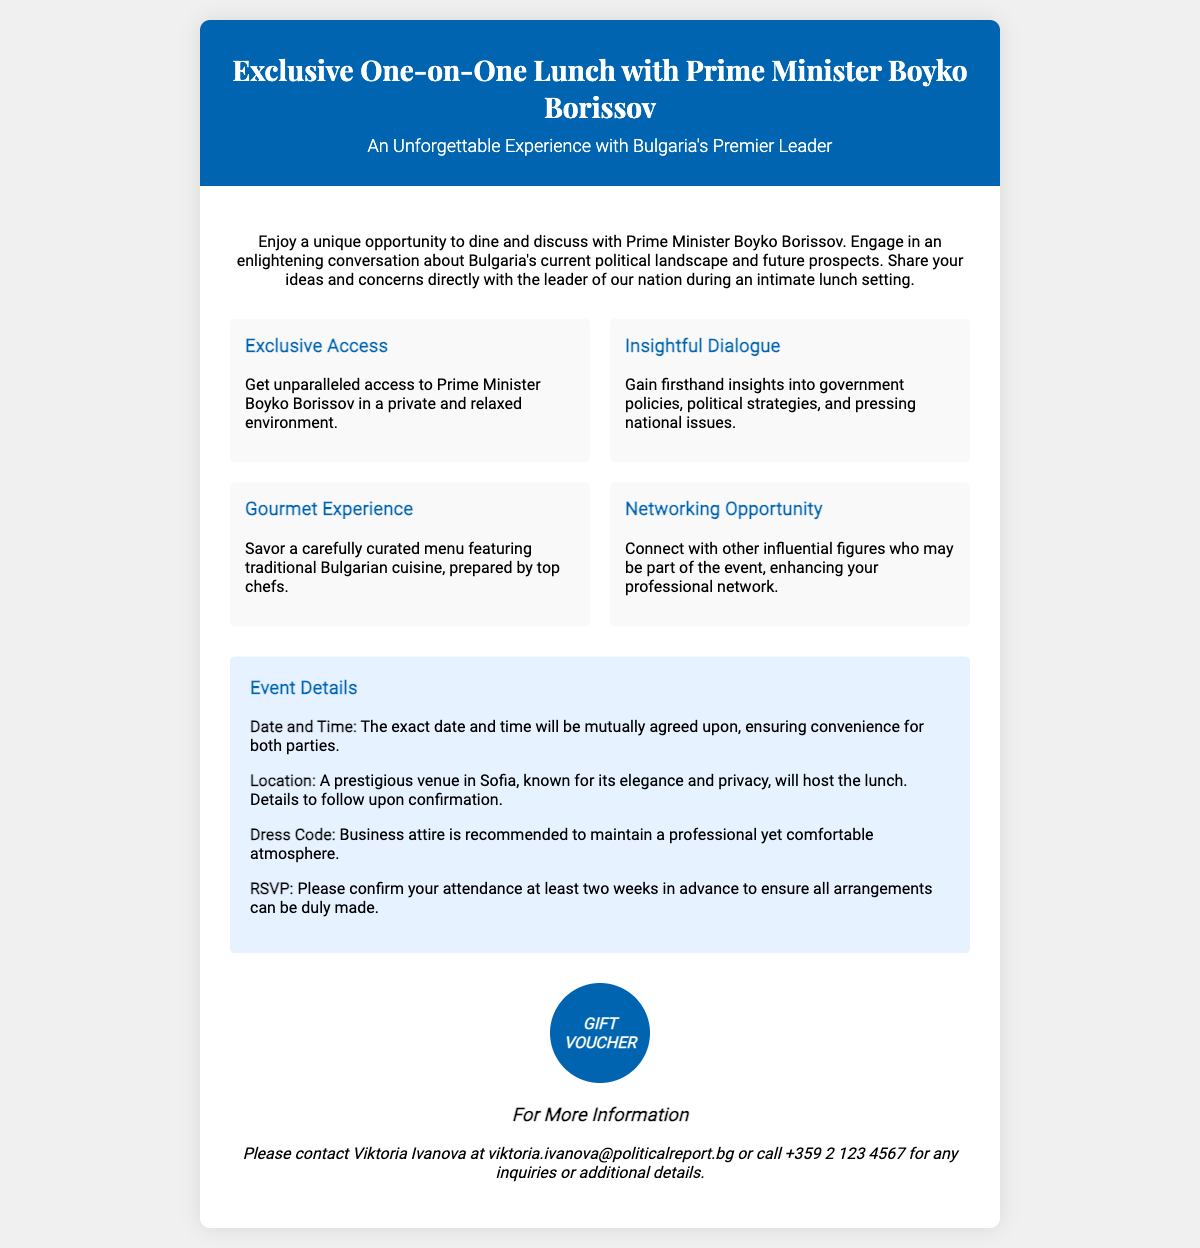What is the title of the event? The title is prominently stated in the header section of the document.
Answer: Exclusive One-on-One Lunch with Prime Minister Boyko Borissov Who is the prominent political figure featured in the lunch? The document specifically names the individual in the title and description.
Answer: Prime Minister Boyko Borissov What type of cuisine will be served during the lunch? The document mentions the culinary theme within the highlights section.
Answer: Traditional Bulgarian cuisine What is recommended attire for the event? The dress code is specifically mentioned in the event details section of the document.
Answer: Business attire How much notice is requested for RSVP? The RSVP requirement is clearly stated in the event details.
Answer: Two weeks What is the purpose of the event? The description provides insight into the main objective of the event.
Answer: To discuss Bulgaria's current political landscape and future prospects Where will the event take place? The document provides a general location description in the event details.
Answer: A prestigious venue in Sofia What should participants do if they have inquiries? The contact information section provides details on whom to contact for queries.
Answer: Contact Viktoria Ivanova What will attendees have the chance to gain from the lunch? The highlights section indicates the beneficial aspect of attending the event.
Answer: Firsthand insights into government policies 